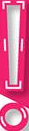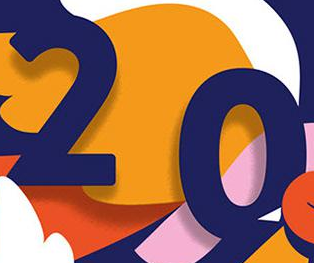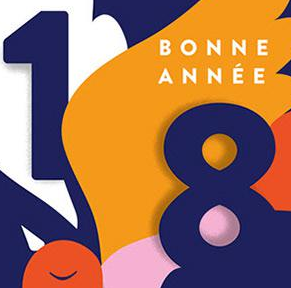What words are shown in these images in order, separated by a semicolon? !; 20; 18 